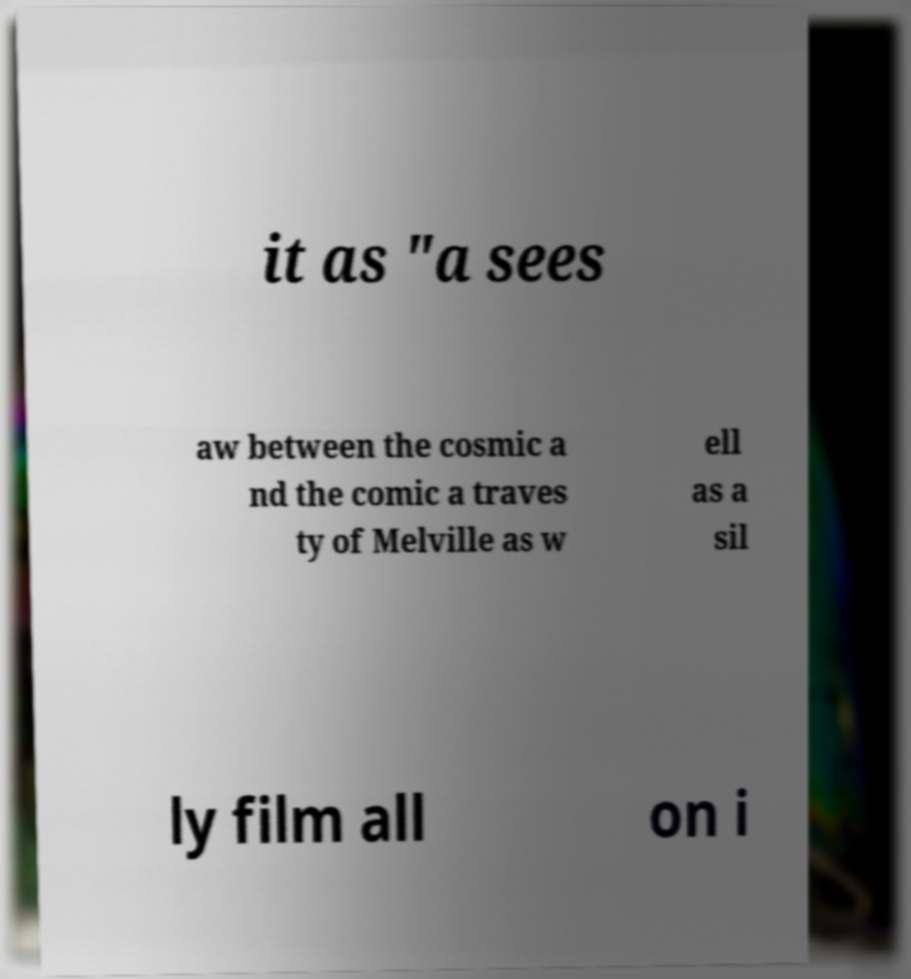There's text embedded in this image that I need extracted. Can you transcribe it verbatim? it as "a sees aw between the cosmic a nd the comic a traves ty of Melville as w ell as a sil ly film all on i 